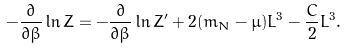<formula> <loc_0><loc_0><loc_500><loc_500>- \frac { \partial } { \partial \beta } \ln Z = - \frac { \partial } { \partial \beta } \ln Z ^ { \prime } + 2 ( m _ { N } - \mu ) L ^ { 3 } - \frac { C } { 2 } L ^ { 3 } .</formula> 